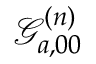Convert formula to latex. <formula><loc_0><loc_0><loc_500><loc_500>\mathcal { G } _ { a , 0 0 } ^ { ( n ) }</formula> 